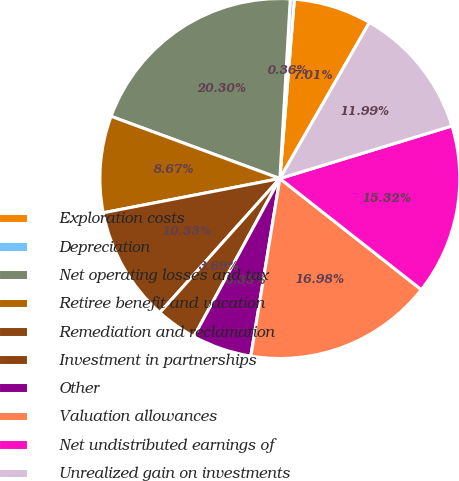<chart> <loc_0><loc_0><loc_500><loc_500><pie_chart><fcel>Exploration costs<fcel>Depreciation<fcel>Net operating losses and tax<fcel>Retiree benefit and vacation<fcel>Remediation and reclamation<fcel>Investment in partnerships<fcel>Other<fcel>Valuation allowances<fcel>Net undistributed earnings of<fcel>Unrealized gain on investments<nl><fcel>7.01%<fcel>0.36%<fcel>20.3%<fcel>8.67%<fcel>10.33%<fcel>3.69%<fcel>5.35%<fcel>16.98%<fcel>15.32%<fcel>11.99%<nl></chart> 